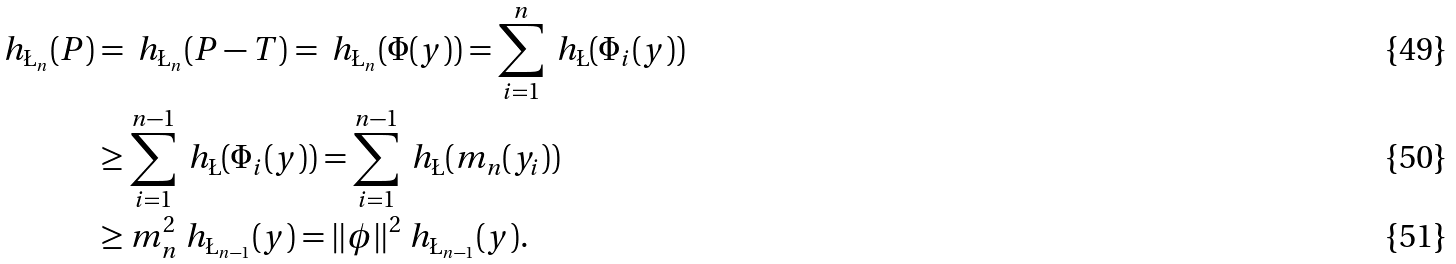Convert formula to latex. <formula><loc_0><loc_0><loc_500><loc_500>\ h _ { \L _ { n } } ( P ) & = \ h _ { \L _ { n } } ( P - T ) = \ h _ { \L _ { n } } ( \Phi ( y ) ) = \sum _ { i = 1 } ^ { n } \ h _ { \L } ( \Phi _ { i } ( y ) ) \\ & \geq \sum _ { i = 1 } ^ { n - 1 } \ h _ { \L } ( \Phi _ { i } ( y ) ) = \sum _ { i = 1 } ^ { n - 1 } \ h _ { \L } ( m _ { n } ( y _ { i } ) ) \\ & \geq m _ { n } ^ { 2 } \ h _ { \L _ { n - 1 } } ( y ) = \| \phi \| ^ { 2 } \ h _ { \L _ { n - 1 } } ( y ) .</formula> 